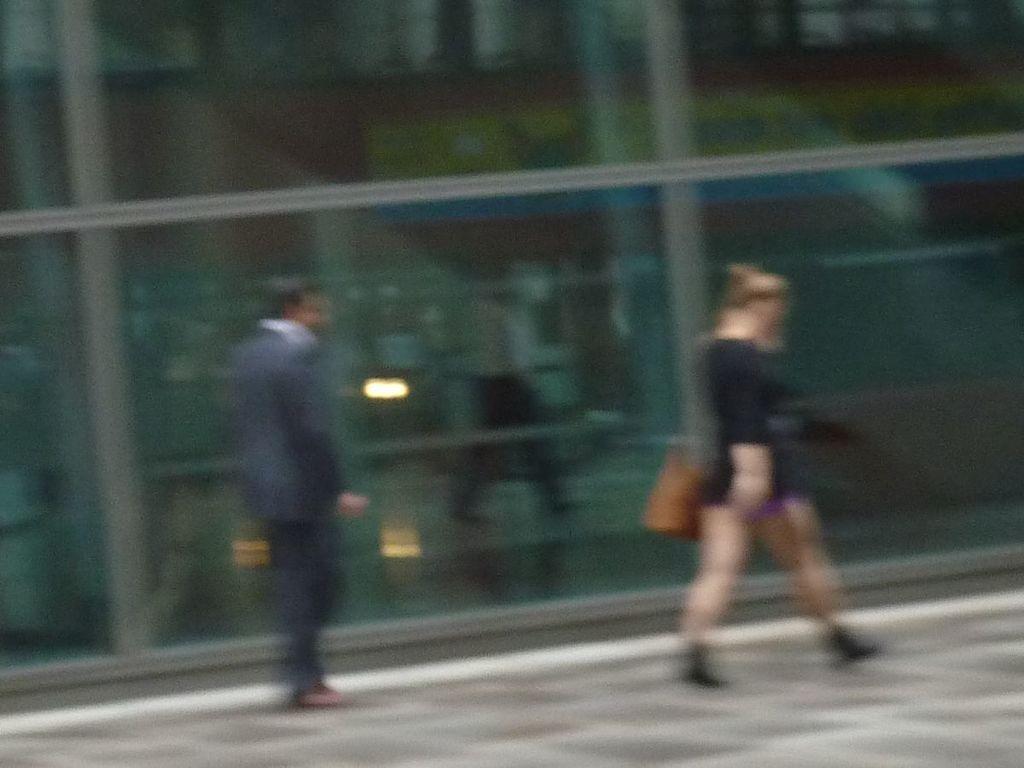Could you give a brief overview of what you see in this image? In this image there is one person standing on the left side,and one women is walking on the right side and holding a wall. There is a glass wall in the background. 